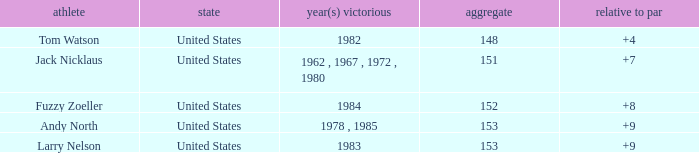What is the To par of Player Andy North with a Total larger than 153? 0.0. 